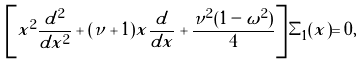<formula> <loc_0><loc_0><loc_500><loc_500>\left [ x ^ { 2 } \frac { d ^ { 2 } } { d x ^ { 2 } } + ( \nu + 1 ) x \frac { d } { d x } + \frac { \nu ^ { 2 } ( 1 - \omega ^ { 2 } ) } { 4 } \right ] \Sigma _ { 1 } ( x ) = 0 ,</formula> 